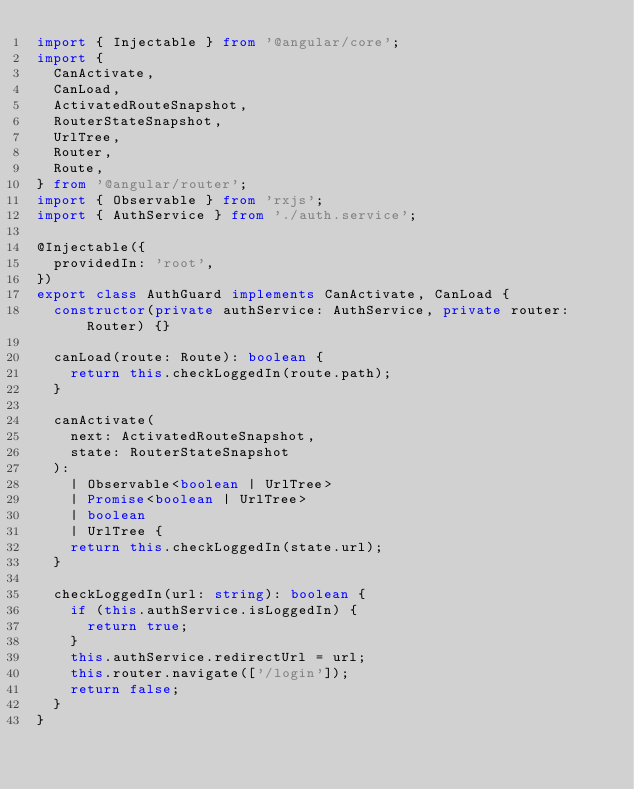Convert code to text. <code><loc_0><loc_0><loc_500><loc_500><_TypeScript_>import { Injectable } from '@angular/core';
import {
  CanActivate,
  CanLoad,
  ActivatedRouteSnapshot,
  RouterStateSnapshot,
  UrlTree,
  Router,
  Route,
} from '@angular/router';
import { Observable } from 'rxjs';
import { AuthService } from './auth.service';

@Injectable({
  providedIn: 'root',
})
export class AuthGuard implements CanActivate, CanLoad {
  constructor(private authService: AuthService, private router: Router) {}

  canLoad(route: Route): boolean {
    return this.checkLoggedIn(route.path);
  }

  canActivate(
    next: ActivatedRouteSnapshot,
    state: RouterStateSnapshot
  ):
    | Observable<boolean | UrlTree>
    | Promise<boolean | UrlTree>
    | boolean
    | UrlTree {
    return this.checkLoggedIn(state.url);
  }

  checkLoggedIn(url: string): boolean {
    if (this.authService.isLoggedIn) {
      return true;
    }
    this.authService.redirectUrl = url;
    this.router.navigate(['/login']);
    return false;
  }
}
</code> 